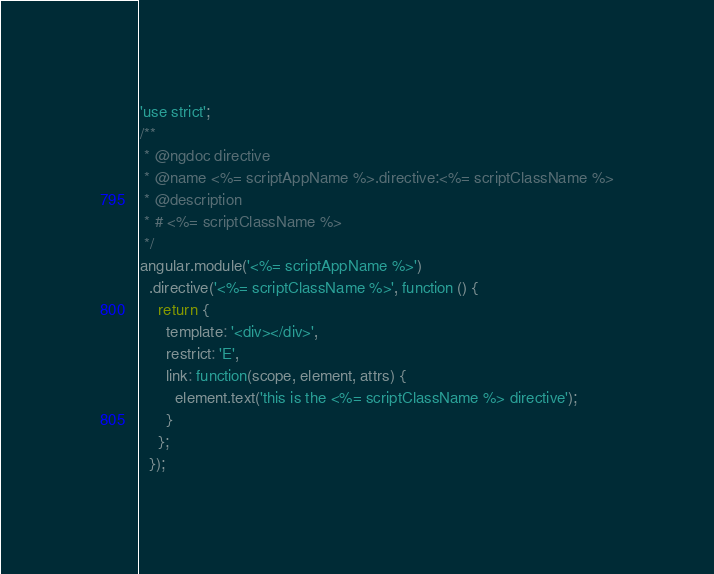<code> <loc_0><loc_0><loc_500><loc_500><_JavaScript_>'use strict';
/**
 * @ngdoc directive
 * @name <%= scriptAppName %>.directive:<%= scriptClassName %>
 * @description
 * # <%= scriptClassName %>
 */
angular.module('<%= scriptAppName %>')
  .directive('<%= scriptClassName %>', function () {
    return {
      template: '<div></div>',
      restrict: 'E',
      link: function(scope, element, attrs) {
        element.text('this is the <%= scriptClassName %> directive');
      }
    };
  });
</code> 